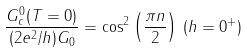<formula> <loc_0><loc_0><loc_500><loc_500>\frac { G _ { c } ^ { 0 } ( T = 0 ) } { ( 2 e ^ { 2 } / h ) G _ { 0 } } = \cos ^ { 2 } \left ( \frac { \pi n } { 2 } \right ) \, ( h = 0 ^ { + } )</formula> 